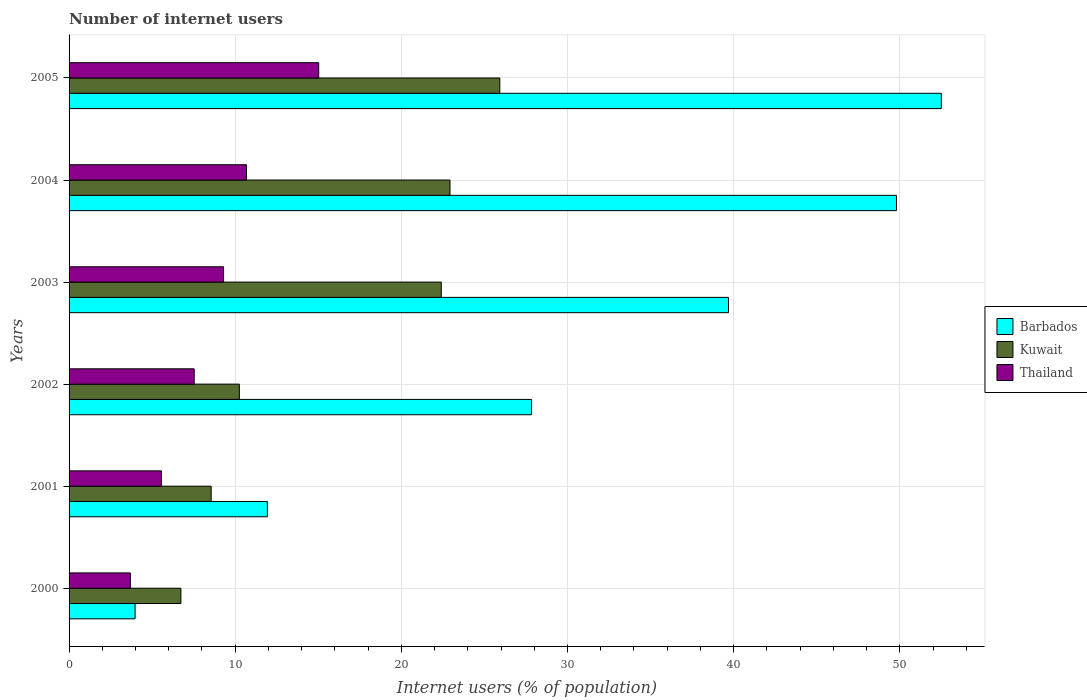Are the number of bars on each tick of the Y-axis equal?
Provide a succinct answer. Yes. How many bars are there on the 2nd tick from the top?
Your answer should be very brief. 3. How many bars are there on the 1st tick from the bottom?
Make the answer very short. 3. In how many cases, is the number of bars for a given year not equal to the number of legend labels?
Keep it short and to the point. 0. What is the number of internet users in Thailand in 2005?
Your response must be concise. 15.03. Across all years, what is the maximum number of internet users in Thailand?
Your answer should be very brief. 15.03. Across all years, what is the minimum number of internet users in Kuwait?
Your response must be concise. 6.73. In which year was the number of internet users in Thailand maximum?
Provide a short and direct response. 2005. What is the total number of internet users in Kuwait in the graph?
Provide a succinct answer. 96.79. What is the difference between the number of internet users in Kuwait in 2000 and that in 2005?
Your answer should be very brief. -19.19. What is the difference between the number of internet users in Thailand in 2000 and the number of internet users in Barbados in 2003?
Your answer should be compact. -36. What is the average number of internet users in Kuwait per year?
Make the answer very short. 16.13. In the year 2004, what is the difference between the number of internet users in Kuwait and number of internet users in Thailand?
Keep it short and to the point. 12.25. What is the ratio of the number of internet users in Barbados in 2000 to that in 2001?
Make the answer very short. 0.33. Is the number of internet users in Kuwait in 2004 less than that in 2005?
Ensure brevity in your answer.  Yes. What is the difference between the highest and the second highest number of internet users in Barbados?
Ensure brevity in your answer.  2.7. What is the difference between the highest and the lowest number of internet users in Thailand?
Provide a succinct answer. 11.34. In how many years, is the number of internet users in Kuwait greater than the average number of internet users in Kuwait taken over all years?
Make the answer very short. 3. Is the sum of the number of internet users in Thailand in 2000 and 2002 greater than the maximum number of internet users in Barbados across all years?
Make the answer very short. No. What does the 2nd bar from the top in 2002 represents?
Make the answer very short. Kuwait. What does the 3rd bar from the bottom in 2004 represents?
Your answer should be compact. Thailand. Is it the case that in every year, the sum of the number of internet users in Thailand and number of internet users in Kuwait is greater than the number of internet users in Barbados?
Make the answer very short. No. Are all the bars in the graph horizontal?
Give a very brief answer. Yes. Does the graph contain grids?
Provide a succinct answer. Yes. How many legend labels are there?
Make the answer very short. 3. What is the title of the graph?
Offer a terse response. Number of internet users. What is the label or title of the X-axis?
Give a very brief answer. Internet users (% of population). What is the Internet users (% of population) of Barbados in 2000?
Your answer should be compact. 3.97. What is the Internet users (% of population) in Kuwait in 2000?
Your answer should be very brief. 6.73. What is the Internet users (% of population) of Thailand in 2000?
Offer a very short reply. 3.69. What is the Internet users (% of population) in Barbados in 2001?
Your answer should be very brief. 11.94. What is the Internet users (% of population) of Kuwait in 2001?
Provide a succinct answer. 8.55. What is the Internet users (% of population) in Thailand in 2001?
Offer a terse response. 5.56. What is the Internet users (% of population) in Barbados in 2002?
Provide a short and direct response. 27.84. What is the Internet users (% of population) in Kuwait in 2002?
Offer a very short reply. 10.25. What is the Internet users (% of population) in Thailand in 2002?
Your answer should be very brief. 7.53. What is the Internet users (% of population) of Barbados in 2003?
Your answer should be compact. 39.69. What is the Internet users (% of population) in Kuwait in 2003?
Give a very brief answer. 22.4. What is the Internet users (% of population) of Thailand in 2003?
Your answer should be compact. 9.3. What is the Internet users (% of population) in Barbados in 2004?
Make the answer very short. 49.8. What is the Internet users (% of population) of Kuwait in 2004?
Offer a very short reply. 22.93. What is the Internet users (% of population) of Thailand in 2004?
Give a very brief answer. 10.68. What is the Internet users (% of population) of Barbados in 2005?
Your answer should be very brief. 52.5. What is the Internet users (% of population) of Kuwait in 2005?
Provide a short and direct response. 25.93. What is the Internet users (% of population) in Thailand in 2005?
Make the answer very short. 15.03. Across all years, what is the maximum Internet users (% of population) in Barbados?
Provide a succinct answer. 52.5. Across all years, what is the maximum Internet users (% of population) of Kuwait?
Give a very brief answer. 25.93. Across all years, what is the maximum Internet users (% of population) of Thailand?
Your response must be concise. 15.03. Across all years, what is the minimum Internet users (% of population) in Barbados?
Keep it short and to the point. 3.97. Across all years, what is the minimum Internet users (% of population) of Kuwait?
Ensure brevity in your answer.  6.73. Across all years, what is the minimum Internet users (% of population) in Thailand?
Provide a short and direct response. 3.69. What is the total Internet users (% of population) of Barbados in the graph?
Provide a short and direct response. 185.74. What is the total Internet users (% of population) of Kuwait in the graph?
Provide a short and direct response. 96.79. What is the total Internet users (% of population) of Thailand in the graph?
Ensure brevity in your answer.  51.78. What is the difference between the Internet users (% of population) of Barbados in 2000 and that in 2001?
Give a very brief answer. -7.96. What is the difference between the Internet users (% of population) of Kuwait in 2000 and that in 2001?
Ensure brevity in your answer.  -1.82. What is the difference between the Internet users (% of population) in Thailand in 2000 and that in 2001?
Ensure brevity in your answer.  -1.87. What is the difference between the Internet users (% of population) in Barbados in 2000 and that in 2002?
Your answer should be very brief. -23.86. What is the difference between the Internet users (% of population) in Kuwait in 2000 and that in 2002?
Ensure brevity in your answer.  -3.52. What is the difference between the Internet users (% of population) in Thailand in 2000 and that in 2002?
Make the answer very short. -3.84. What is the difference between the Internet users (% of population) in Barbados in 2000 and that in 2003?
Offer a very short reply. -35.72. What is the difference between the Internet users (% of population) of Kuwait in 2000 and that in 2003?
Offer a very short reply. -15.67. What is the difference between the Internet users (% of population) in Thailand in 2000 and that in 2003?
Your answer should be very brief. -5.61. What is the difference between the Internet users (% of population) in Barbados in 2000 and that in 2004?
Your answer should be compact. -45.83. What is the difference between the Internet users (% of population) of Kuwait in 2000 and that in 2004?
Ensure brevity in your answer.  -16.2. What is the difference between the Internet users (% of population) in Thailand in 2000 and that in 2004?
Offer a very short reply. -6.99. What is the difference between the Internet users (% of population) in Barbados in 2000 and that in 2005?
Offer a terse response. -48.53. What is the difference between the Internet users (% of population) of Kuwait in 2000 and that in 2005?
Offer a very short reply. -19.19. What is the difference between the Internet users (% of population) of Thailand in 2000 and that in 2005?
Your answer should be very brief. -11.34. What is the difference between the Internet users (% of population) of Barbados in 2001 and that in 2002?
Keep it short and to the point. -15.9. What is the difference between the Internet users (% of population) in Kuwait in 2001 and that in 2002?
Keep it short and to the point. -1.7. What is the difference between the Internet users (% of population) in Thailand in 2001 and that in 2002?
Provide a short and direct response. -1.97. What is the difference between the Internet users (% of population) of Barbados in 2001 and that in 2003?
Provide a short and direct response. -27.75. What is the difference between the Internet users (% of population) of Kuwait in 2001 and that in 2003?
Give a very brief answer. -13.85. What is the difference between the Internet users (% of population) in Thailand in 2001 and that in 2003?
Your answer should be very brief. -3.74. What is the difference between the Internet users (% of population) of Barbados in 2001 and that in 2004?
Your answer should be very brief. -37.86. What is the difference between the Internet users (% of population) in Kuwait in 2001 and that in 2004?
Your response must be concise. -14.38. What is the difference between the Internet users (% of population) in Thailand in 2001 and that in 2004?
Keep it short and to the point. -5.12. What is the difference between the Internet users (% of population) in Barbados in 2001 and that in 2005?
Your response must be concise. -40.56. What is the difference between the Internet users (% of population) in Kuwait in 2001 and that in 2005?
Give a very brief answer. -17.37. What is the difference between the Internet users (% of population) in Thailand in 2001 and that in 2005?
Make the answer very short. -9.47. What is the difference between the Internet users (% of population) of Barbados in 2002 and that in 2003?
Offer a very short reply. -11.85. What is the difference between the Internet users (% of population) in Kuwait in 2002 and that in 2003?
Make the answer very short. -12.15. What is the difference between the Internet users (% of population) in Thailand in 2002 and that in 2003?
Offer a very short reply. -1.77. What is the difference between the Internet users (% of population) of Barbados in 2002 and that in 2004?
Your answer should be very brief. -21.96. What is the difference between the Internet users (% of population) of Kuwait in 2002 and that in 2004?
Provide a short and direct response. -12.68. What is the difference between the Internet users (% of population) of Thailand in 2002 and that in 2004?
Offer a terse response. -3.15. What is the difference between the Internet users (% of population) of Barbados in 2002 and that in 2005?
Keep it short and to the point. -24.66. What is the difference between the Internet users (% of population) in Kuwait in 2002 and that in 2005?
Make the answer very short. -15.68. What is the difference between the Internet users (% of population) in Thailand in 2002 and that in 2005?
Make the answer very short. -7.49. What is the difference between the Internet users (% of population) of Barbados in 2003 and that in 2004?
Provide a succinct answer. -10.11. What is the difference between the Internet users (% of population) of Kuwait in 2003 and that in 2004?
Offer a terse response. -0.52. What is the difference between the Internet users (% of population) in Thailand in 2003 and that in 2004?
Your response must be concise. -1.38. What is the difference between the Internet users (% of population) in Barbados in 2003 and that in 2005?
Provide a succinct answer. -12.81. What is the difference between the Internet users (% of population) in Kuwait in 2003 and that in 2005?
Give a very brief answer. -3.52. What is the difference between the Internet users (% of population) in Thailand in 2003 and that in 2005?
Offer a terse response. -5.73. What is the difference between the Internet users (% of population) in Barbados in 2004 and that in 2005?
Offer a terse response. -2.7. What is the difference between the Internet users (% of population) in Kuwait in 2004 and that in 2005?
Provide a short and direct response. -3. What is the difference between the Internet users (% of population) in Thailand in 2004 and that in 2005?
Make the answer very short. -4.35. What is the difference between the Internet users (% of population) of Barbados in 2000 and the Internet users (% of population) of Kuwait in 2001?
Provide a succinct answer. -4.58. What is the difference between the Internet users (% of population) of Barbados in 2000 and the Internet users (% of population) of Thailand in 2001?
Offer a very short reply. -1.58. What is the difference between the Internet users (% of population) in Kuwait in 2000 and the Internet users (% of population) in Thailand in 2001?
Provide a succinct answer. 1.18. What is the difference between the Internet users (% of population) in Barbados in 2000 and the Internet users (% of population) in Kuwait in 2002?
Provide a short and direct response. -6.28. What is the difference between the Internet users (% of population) of Barbados in 2000 and the Internet users (% of population) of Thailand in 2002?
Your response must be concise. -3.56. What is the difference between the Internet users (% of population) in Kuwait in 2000 and the Internet users (% of population) in Thailand in 2002?
Your answer should be very brief. -0.8. What is the difference between the Internet users (% of population) of Barbados in 2000 and the Internet users (% of population) of Kuwait in 2003?
Ensure brevity in your answer.  -18.43. What is the difference between the Internet users (% of population) of Barbados in 2000 and the Internet users (% of population) of Thailand in 2003?
Your answer should be compact. -5.33. What is the difference between the Internet users (% of population) of Kuwait in 2000 and the Internet users (% of population) of Thailand in 2003?
Keep it short and to the point. -2.57. What is the difference between the Internet users (% of population) in Barbados in 2000 and the Internet users (% of population) in Kuwait in 2004?
Make the answer very short. -18.95. What is the difference between the Internet users (% of population) in Barbados in 2000 and the Internet users (% of population) in Thailand in 2004?
Your answer should be compact. -6.7. What is the difference between the Internet users (% of population) in Kuwait in 2000 and the Internet users (% of population) in Thailand in 2004?
Your response must be concise. -3.95. What is the difference between the Internet users (% of population) in Barbados in 2000 and the Internet users (% of population) in Kuwait in 2005?
Offer a very short reply. -21.95. What is the difference between the Internet users (% of population) in Barbados in 2000 and the Internet users (% of population) in Thailand in 2005?
Offer a very short reply. -11.05. What is the difference between the Internet users (% of population) in Kuwait in 2000 and the Internet users (% of population) in Thailand in 2005?
Offer a very short reply. -8.29. What is the difference between the Internet users (% of population) in Barbados in 2001 and the Internet users (% of population) in Kuwait in 2002?
Provide a succinct answer. 1.69. What is the difference between the Internet users (% of population) in Barbados in 2001 and the Internet users (% of population) in Thailand in 2002?
Offer a very short reply. 4.41. What is the difference between the Internet users (% of population) of Kuwait in 2001 and the Internet users (% of population) of Thailand in 2002?
Your answer should be very brief. 1.02. What is the difference between the Internet users (% of population) of Barbados in 2001 and the Internet users (% of population) of Kuwait in 2003?
Give a very brief answer. -10.47. What is the difference between the Internet users (% of population) in Barbados in 2001 and the Internet users (% of population) in Thailand in 2003?
Your response must be concise. 2.64. What is the difference between the Internet users (% of population) in Kuwait in 2001 and the Internet users (% of population) in Thailand in 2003?
Your response must be concise. -0.75. What is the difference between the Internet users (% of population) in Barbados in 2001 and the Internet users (% of population) in Kuwait in 2004?
Give a very brief answer. -10.99. What is the difference between the Internet users (% of population) of Barbados in 2001 and the Internet users (% of population) of Thailand in 2004?
Make the answer very short. 1.26. What is the difference between the Internet users (% of population) of Kuwait in 2001 and the Internet users (% of population) of Thailand in 2004?
Make the answer very short. -2.13. What is the difference between the Internet users (% of population) in Barbados in 2001 and the Internet users (% of population) in Kuwait in 2005?
Your answer should be compact. -13.99. What is the difference between the Internet users (% of population) in Barbados in 2001 and the Internet users (% of population) in Thailand in 2005?
Offer a terse response. -3.09. What is the difference between the Internet users (% of population) of Kuwait in 2001 and the Internet users (% of population) of Thailand in 2005?
Ensure brevity in your answer.  -6.47. What is the difference between the Internet users (% of population) of Barbados in 2002 and the Internet users (% of population) of Kuwait in 2003?
Your answer should be compact. 5.43. What is the difference between the Internet users (% of population) of Barbados in 2002 and the Internet users (% of population) of Thailand in 2003?
Your response must be concise. 18.54. What is the difference between the Internet users (% of population) of Kuwait in 2002 and the Internet users (% of population) of Thailand in 2003?
Ensure brevity in your answer.  0.95. What is the difference between the Internet users (% of population) in Barbados in 2002 and the Internet users (% of population) in Kuwait in 2004?
Provide a succinct answer. 4.91. What is the difference between the Internet users (% of population) of Barbados in 2002 and the Internet users (% of population) of Thailand in 2004?
Keep it short and to the point. 17.16. What is the difference between the Internet users (% of population) of Kuwait in 2002 and the Internet users (% of population) of Thailand in 2004?
Your answer should be very brief. -0.43. What is the difference between the Internet users (% of population) of Barbados in 2002 and the Internet users (% of population) of Kuwait in 2005?
Your answer should be compact. 1.91. What is the difference between the Internet users (% of population) of Barbados in 2002 and the Internet users (% of population) of Thailand in 2005?
Provide a short and direct response. 12.81. What is the difference between the Internet users (% of population) in Kuwait in 2002 and the Internet users (% of population) in Thailand in 2005?
Provide a short and direct response. -4.78. What is the difference between the Internet users (% of population) of Barbados in 2003 and the Internet users (% of population) of Kuwait in 2004?
Make the answer very short. 16.76. What is the difference between the Internet users (% of population) in Barbados in 2003 and the Internet users (% of population) in Thailand in 2004?
Make the answer very short. 29.01. What is the difference between the Internet users (% of population) in Kuwait in 2003 and the Internet users (% of population) in Thailand in 2004?
Provide a short and direct response. 11.73. What is the difference between the Internet users (% of population) in Barbados in 2003 and the Internet users (% of population) in Kuwait in 2005?
Provide a short and direct response. 13.76. What is the difference between the Internet users (% of population) in Barbados in 2003 and the Internet users (% of population) in Thailand in 2005?
Your answer should be very brief. 24.66. What is the difference between the Internet users (% of population) in Kuwait in 2003 and the Internet users (% of population) in Thailand in 2005?
Keep it short and to the point. 7.38. What is the difference between the Internet users (% of population) of Barbados in 2004 and the Internet users (% of population) of Kuwait in 2005?
Offer a terse response. 23.87. What is the difference between the Internet users (% of population) of Barbados in 2004 and the Internet users (% of population) of Thailand in 2005?
Give a very brief answer. 34.77. What is the difference between the Internet users (% of population) in Kuwait in 2004 and the Internet users (% of population) in Thailand in 2005?
Offer a very short reply. 7.9. What is the average Internet users (% of population) of Barbados per year?
Ensure brevity in your answer.  30.96. What is the average Internet users (% of population) in Kuwait per year?
Your answer should be compact. 16.13. What is the average Internet users (% of population) of Thailand per year?
Your response must be concise. 8.63. In the year 2000, what is the difference between the Internet users (% of population) of Barbados and Internet users (% of population) of Kuwait?
Offer a very short reply. -2.76. In the year 2000, what is the difference between the Internet users (% of population) in Barbados and Internet users (% of population) in Thailand?
Offer a very short reply. 0.28. In the year 2000, what is the difference between the Internet users (% of population) of Kuwait and Internet users (% of population) of Thailand?
Your answer should be very brief. 3.04. In the year 2001, what is the difference between the Internet users (% of population) of Barbados and Internet users (% of population) of Kuwait?
Make the answer very short. 3.38. In the year 2001, what is the difference between the Internet users (% of population) of Barbados and Internet users (% of population) of Thailand?
Provide a short and direct response. 6.38. In the year 2001, what is the difference between the Internet users (% of population) in Kuwait and Internet users (% of population) in Thailand?
Provide a short and direct response. 3. In the year 2002, what is the difference between the Internet users (% of population) in Barbados and Internet users (% of population) in Kuwait?
Keep it short and to the point. 17.59. In the year 2002, what is the difference between the Internet users (% of population) in Barbados and Internet users (% of population) in Thailand?
Give a very brief answer. 20.31. In the year 2002, what is the difference between the Internet users (% of population) of Kuwait and Internet users (% of population) of Thailand?
Ensure brevity in your answer.  2.72. In the year 2003, what is the difference between the Internet users (% of population) in Barbados and Internet users (% of population) in Kuwait?
Keep it short and to the point. 17.29. In the year 2003, what is the difference between the Internet users (% of population) of Barbados and Internet users (% of population) of Thailand?
Your answer should be compact. 30.39. In the year 2003, what is the difference between the Internet users (% of population) of Kuwait and Internet users (% of population) of Thailand?
Offer a very short reply. 13.1. In the year 2004, what is the difference between the Internet users (% of population) in Barbados and Internet users (% of population) in Kuwait?
Offer a terse response. 26.87. In the year 2004, what is the difference between the Internet users (% of population) in Barbados and Internet users (% of population) in Thailand?
Offer a terse response. 39.12. In the year 2004, what is the difference between the Internet users (% of population) of Kuwait and Internet users (% of population) of Thailand?
Provide a succinct answer. 12.25. In the year 2005, what is the difference between the Internet users (% of population) in Barbados and Internet users (% of population) in Kuwait?
Offer a terse response. 26.57. In the year 2005, what is the difference between the Internet users (% of population) in Barbados and Internet users (% of population) in Thailand?
Your answer should be compact. 37.47. In the year 2005, what is the difference between the Internet users (% of population) in Kuwait and Internet users (% of population) in Thailand?
Ensure brevity in your answer.  10.9. What is the ratio of the Internet users (% of population) in Barbados in 2000 to that in 2001?
Offer a very short reply. 0.33. What is the ratio of the Internet users (% of population) in Kuwait in 2000 to that in 2001?
Make the answer very short. 0.79. What is the ratio of the Internet users (% of population) of Thailand in 2000 to that in 2001?
Your answer should be compact. 0.66. What is the ratio of the Internet users (% of population) in Barbados in 2000 to that in 2002?
Make the answer very short. 0.14. What is the ratio of the Internet users (% of population) of Kuwait in 2000 to that in 2002?
Keep it short and to the point. 0.66. What is the ratio of the Internet users (% of population) of Thailand in 2000 to that in 2002?
Your response must be concise. 0.49. What is the ratio of the Internet users (% of population) of Barbados in 2000 to that in 2003?
Offer a very short reply. 0.1. What is the ratio of the Internet users (% of population) in Kuwait in 2000 to that in 2003?
Provide a short and direct response. 0.3. What is the ratio of the Internet users (% of population) of Thailand in 2000 to that in 2003?
Provide a short and direct response. 0.4. What is the ratio of the Internet users (% of population) in Barbados in 2000 to that in 2004?
Make the answer very short. 0.08. What is the ratio of the Internet users (% of population) in Kuwait in 2000 to that in 2004?
Your answer should be very brief. 0.29. What is the ratio of the Internet users (% of population) of Thailand in 2000 to that in 2004?
Provide a succinct answer. 0.35. What is the ratio of the Internet users (% of population) in Barbados in 2000 to that in 2005?
Offer a very short reply. 0.08. What is the ratio of the Internet users (% of population) of Kuwait in 2000 to that in 2005?
Your answer should be compact. 0.26. What is the ratio of the Internet users (% of population) of Thailand in 2000 to that in 2005?
Your answer should be very brief. 0.25. What is the ratio of the Internet users (% of population) in Barbados in 2001 to that in 2002?
Your answer should be compact. 0.43. What is the ratio of the Internet users (% of population) of Kuwait in 2001 to that in 2002?
Provide a succinct answer. 0.83. What is the ratio of the Internet users (% of population) in Thailand in 2001 to that in 2002?
Ensure brevity in your answer.  0.74. What is the ratio of the Internet users (% of population) of Barbados in 2001 to that in 2003?
Provide a succinct answer. 0.3. What is the ratio of the Internet users (% of population) of Kuwait in 2001 to that in 2003?
Keep it short and to the point. 0.38. What is the ratio of the Internet users (% of population) in Thailand in 2001 to that in 2003?
Your answer should be very brief. 0.6. What is the ratio of the Internet users (% of population) in Barbados in 2001 to that in 2004?
Offer a terse response. 0.24. What is the ratio of the Internet users (% of population) of Kuwait in 2001 to that in 2004?
Your response must be concise. 0.37. What is the ratio of the Internet users (% of population) of Thailand in 2001 to that in 2004?
Offer a very short reply. 0.52. What is the ratio of the Internet users (% of population) of Barbados in 2001 to that in 2005?
Your answer should be compact. 0.23. What is the ratio of the Internet users (% of population) of Kuwait in 2001 to that in 2005?
Provide a short and direct response. 0.33. What is the ratio of the Internet users (% of population) of Thailand in 2001 to that in 2005?
Give a very brief answer. 0.37. What is the ratio of the Internet users (% of population) in Barbados in 2002 to that in 2003?
Give a very brief answer. 0.7. What is the ratio of the Internet users (% of population) of Kuwait in 2002 to that in 2003?
Your answer should be very brief. 0.46. What is the ratio of the Internet users (% of population) of Thailand in 2002 to that in 2003?
Your answer should be compact. 0.81. What is the ratio of the Internet users (% of population) in Barbados in 2002 to that in 2004?
Make the answer very short. 0.56. What is the ratio of the Internet users (% of population) in Kuwait in 2002 to that in 2004?
Provide a succinct answer. 0.45. What is the ratio of the Internet users (% of population) of Thailand in 2002 to that in 2004?
Provide a short and direct response. 0.71. What is the ratio of the Internet users (% of population) in Barbados in 2002 to that in 2005?
Make the answer very short. 0.53. What is the ratio of the Internet users (% of population) of Kuwait in 2002 to that in 2005?
Provide a short and direct response. 0.4. What is the ratio of the Internet users (% of population) in Thailand in 2002 to that in 2005?
Your answer should be very brief. 0.5. What is the ratio of the Internet users (% of population) in Barbados in 2003 to that in 2004?
Ensure brevity in your answer.  0.8. What is the ratio of the Internet users (% of population) of Kuwait in 2003 to that in 2004?
Give a very brief answer. 0.98. What is the ratio of the Internet users (% of population) in Thailand in 2003 to that in 2004?
Your response must be concise. 0.87. What is the ratio of the Internet users (% of population) in Barbados in 2003 to that in 2005?
Give a very brief answer. 0.76. What is the ratio of the Internet users (% of population) of Kuwait in 2003 to that in 2005?
Offer a terse response. 0.86. What is the ratio of the Internet users (% of population) of Thailand in 2003 to that in 2005?
Ensure brevity in your answer.  0.62. What is the ratio of the Internet users (% of population) in Barbados in 2004 to that in 2005?
Ensure brevity in your answer.  0.95. What is the ratio of the Internet users (% of population) in Kuwait in 2004 to that in 2005?
Offer a very short reply. 0.88. What is the ratio of the Internet users (% of population) in Thailand in 2004 to that in 2005?
Your answer should be very brief. 0.71. What is the difference between the highest and the second highest Internet users (% of population) in Barbados?
Your response must be concise. 2.7. What is the difference between the highest and the second highest Internet users (% of population) of Kuwait?
Offer a terse response. 3. What is the difference between the highest and the second highest Internet users (% of population) of Thailand?
Provide a short and direct response. 4.35. What is the difference between the highest and the lowest Internet users (% of population) in Barbados?
Ensure brevity in your answer.  48.53. What is the difference between the highest and the lowest Internet users (% of population) of Kuwait?
Offer a very short reply. 19.19. What is the difference between the highest and the lowest Internet users (% of population) in Thailand?
Offer a very short reply. 11.34. 